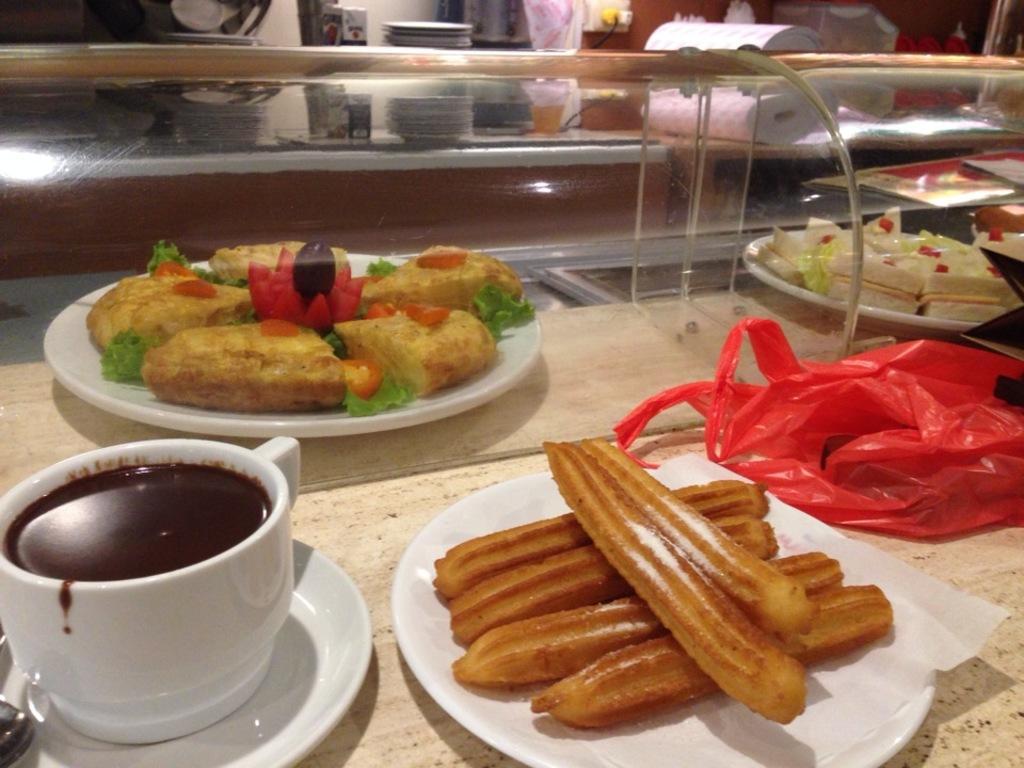Describe this image in one or two sentences. In this picture we can see plates, a saucer with a cup, spoon and some food items on an object. Behind the plates there is a glass object and other things. 